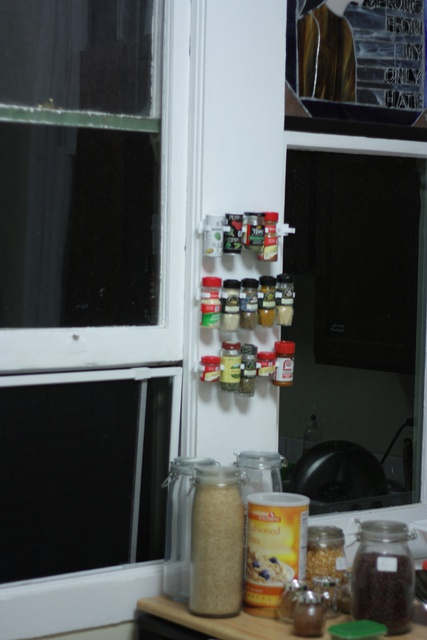Describe the objects in this image and their specific colors. I can see bottle in black and gray tones, bottle in black, gray, and darkgray tones, bottle in black, gray, and darkgray tones, bottle in black, gray, and darkgray tones, and bottle in black, gray, darkgray, and olive tones in this image. 